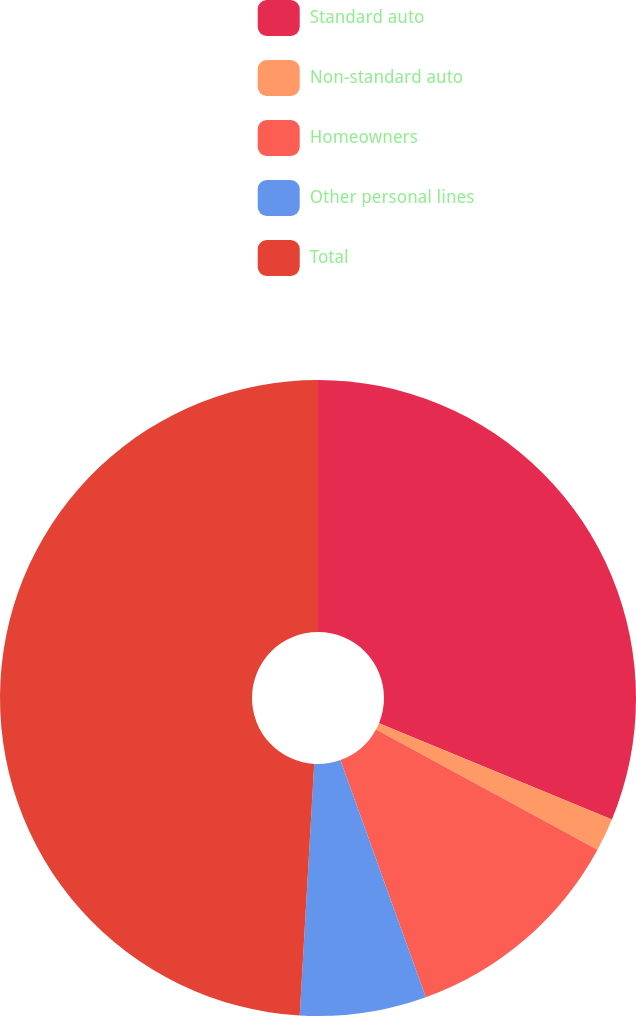Convert chart. <chart><loc_0><loc_0><loc_500><loc_500><pie_chart><fcel>Standard auto<fcel>Non-standard auto<fcel>Homeowners<fcel>Other personal lines<fcel>Total<nl><fcel>31.23%<fcel>1.68%<fcel>11.58%<fcel>6.42%<fcel>49.08%<nl></chart> 